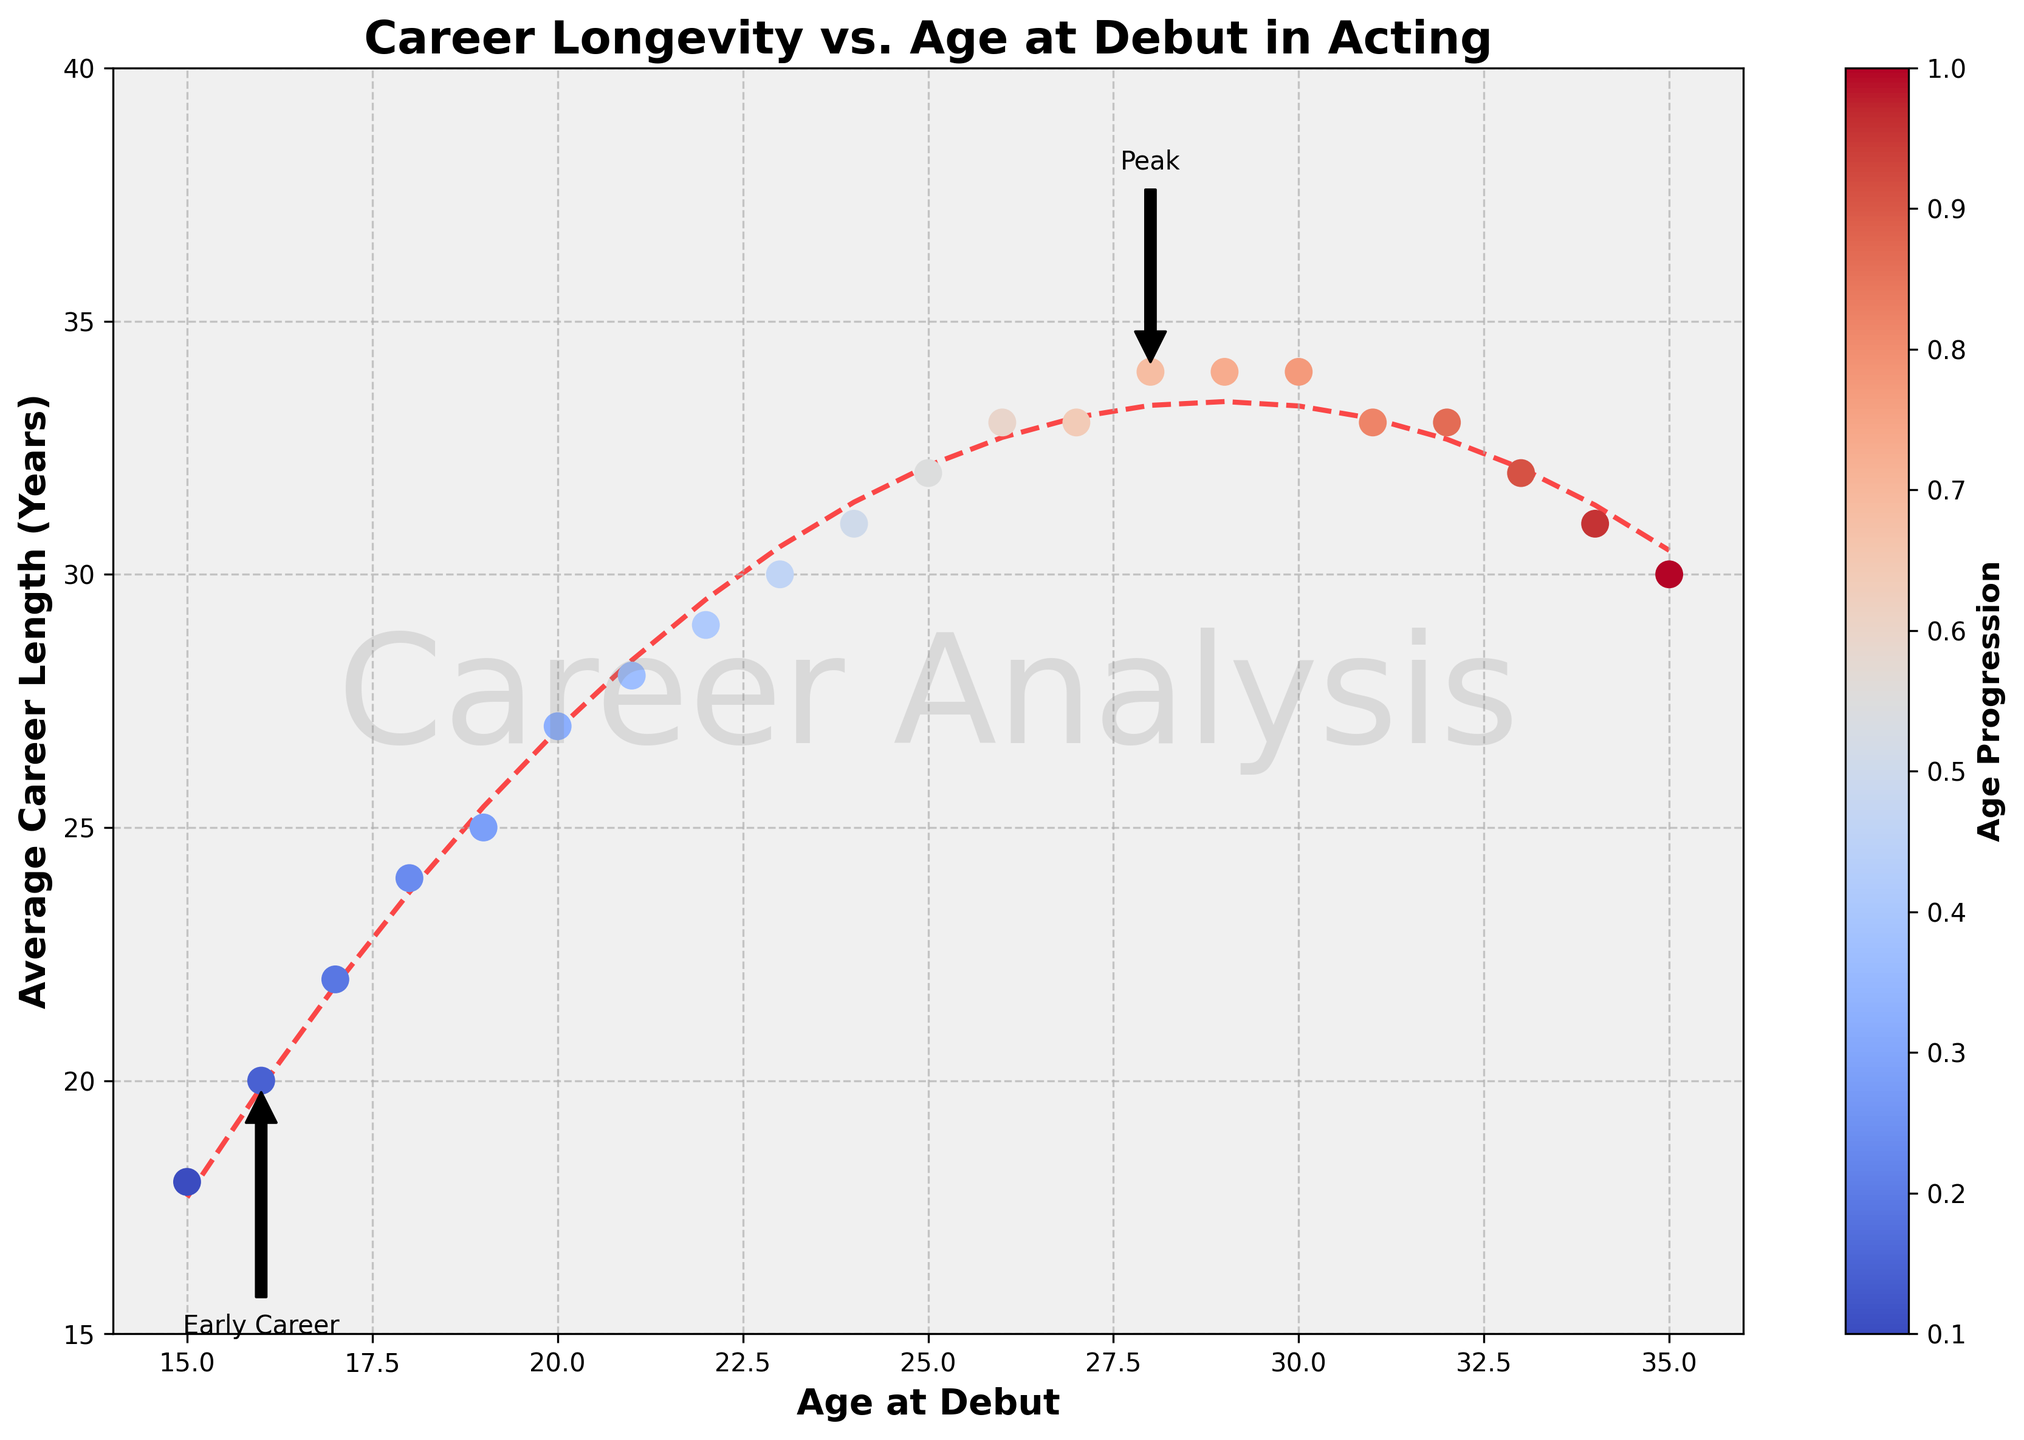What is the career length for actors who debut at age 19? The figure shows the average career length based on the age at debut. Looking at the x-axis for age 19 and tracing vertically to the corresponding y-axis, the career length is 25 years.
Answer: 25 years Does the average career length increase consistently with age at debut? Observing the trend line and the data points in the figure, career length generally increases with age at debut until around age 30, where it then stabilizes and slightly decreases after age 33.
Answer: No At what debut age is the peak average career length achieved according to the trend line? The trend line peaks at age 28 indicating the longest average career length. The annotation 'Peak' further confirms this age.
Answer: 28 How does the average career length change from actors debuting at age 25 to those debuting at age 35? The data shows that those who debut at age 25 have an average career length of 32 years, while those debuting at age 35 have an average career length of 30 years. This shows a decrease of 2 years.
Answer: Decrease by 2 years Which age range of debuting actors has the steepest increase in average career length? The slope of the trend line indicates the steepest increase in the segment from ages 15 to 25, where the average career length rises from 18 to 32 years at a notable rate.
Answer: 15-25 years What is the difference in career length between actors who debut at age 16 and those at age 32? According to the plot, career length for those debuting at 16 is 20 years, and for those at 32 is 33 years. The difference is calculated as 33 - 20, which is 13 years.
Answer: 13 years Is there a particular trend observed for actors who debut after age 30? The line chart shows a slight decline or stabilization in average career length for actors debuting after age 30. The values hover around 33-30 years without significant increase.
Answer: Slight decline/stabilization What visual features indicate the overall trend of career longevity with debut age? The figure includes a gradient-colored scatter plot and a red dashed trend line which visually depicts the relationship. The gradient color transition and the rising then stabilizing trend line clearly show the trajectory of average career lengths.
Answer: Gradient, red dashed trend line How do the career lengths of actors who debut at ages 18 and 33 compare? The data shows that the career length for a debut at age 18 is 24 years, and for age 33, it is 32 years. Comparing these, actors debuting at age 33 have an 8-year longer career on average.
Answer: 8 years longer What does the color bar in the plot represent? The color bar with the title 'Age Progression' indicates that the color gradients on the scatter points correspond to the actors' age at debut, with a transition from cooler to warmer colors indicating increase in age.
Answer: Age Progression 